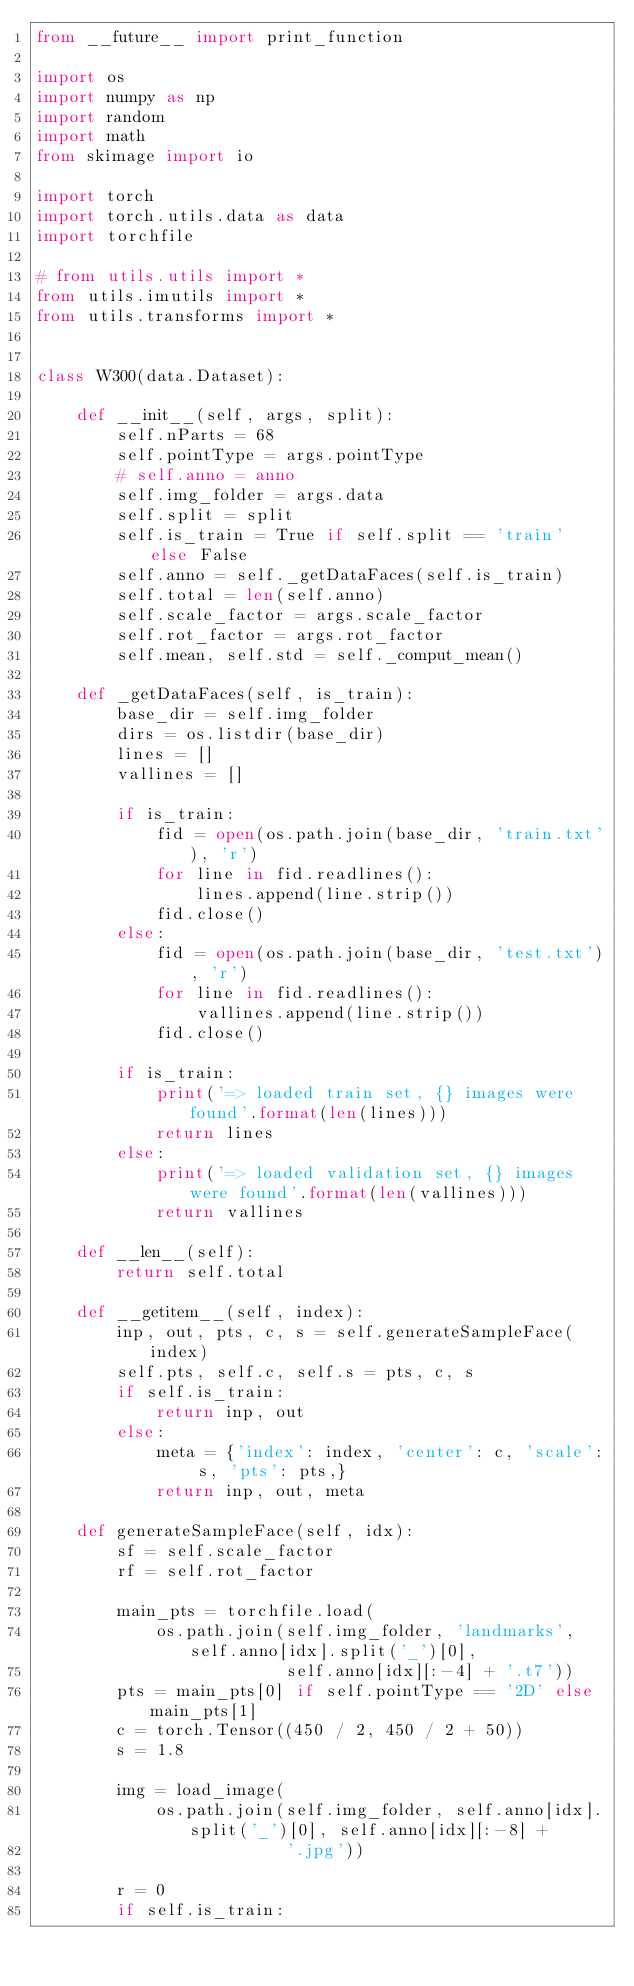Convert code to text. <code><loc_0><loc_0><loc_500><loc_500><_Python_>from __future__ import print_function

import os
import numpy as np
import random
import math
from skimage import io

import torch
import torch.utils.data as data
import torchfile

# from utils.utils import *
from utils.imutils import *
from utils.transforms import *


class W300(data.Dataset):

    def __init__(self, args, split):
        self.nParts = 68
        self.pointType = args.pointType
        # self.anno = anno
        self.img_folder = args.data
        self.split = split
        self.is_train = True if self.split == 'train' else False
        self.anno = self._getDataFaces(self.is_train)
        self.total = len(self.anno)
        self.scale_factor = args.scale_factor
        self.rot_factor = args.rot_factor
        self.mean, self.std = self._comput_mean()

    def _getDataFaces(self, is_train):
        base_dir = self.img_folder
        dirs = os.listdir(base_dir)
        lines = []
        vallines = []

        if is_train:
            fid = open(os.path.join(base_dir, 'train.txt'), 'r')
            for line in fid.readlines():
                lines.append(line.strip())
            fid.close()
        else:
            fid = open(os.path.join(base_dir, 'test.txt'), 'r')
            for line in fid.readlines():
                vallines.append(line.strip())
            fid.close()

        if is_train:
            print('=> loaded train set, {} images were found'.format(len(lines)))
            return lines
        else:
            print('=> loaded validation set, {} images were found'.format(len(vallines)))
            return vallines

    def __len__(self):
        return self.total

    def __getitem__(self, index):
        inp, out, pts, c, s = self.generateSampleFace(index)
        self.pts, self.c, self.s = pts, c, s
        if self.is_train:
            return inp, out
        else:
            meta = {'index': index, 'center': c, 'scale': s, 'pts': pts,}
            return inp, out, meta

    def generateSampleFace(self, idx):
        sf = self.scale_factor
        rf = self.rot_factor

        main_pts = torchfile.load(
            os.path.join(self.img_folder, 'landmarks', self.anno[idx].split('_')[0],
                         self.anno[idx][:-4] + '.t7'))
        pts = main_pts[0] if self.pointType == '2D' else main_pts[1]
        c = torch.Tensor((450 / 2, 450 / 2 + 50))
        s = 1.8

        img = load_image(
            os.path.join(self.img_folder, self.anno[idx].split('_')[0], self.anno[idx][:-8] +
                         '.jpg'))

        r = 0
        if self.is_train:</code> 